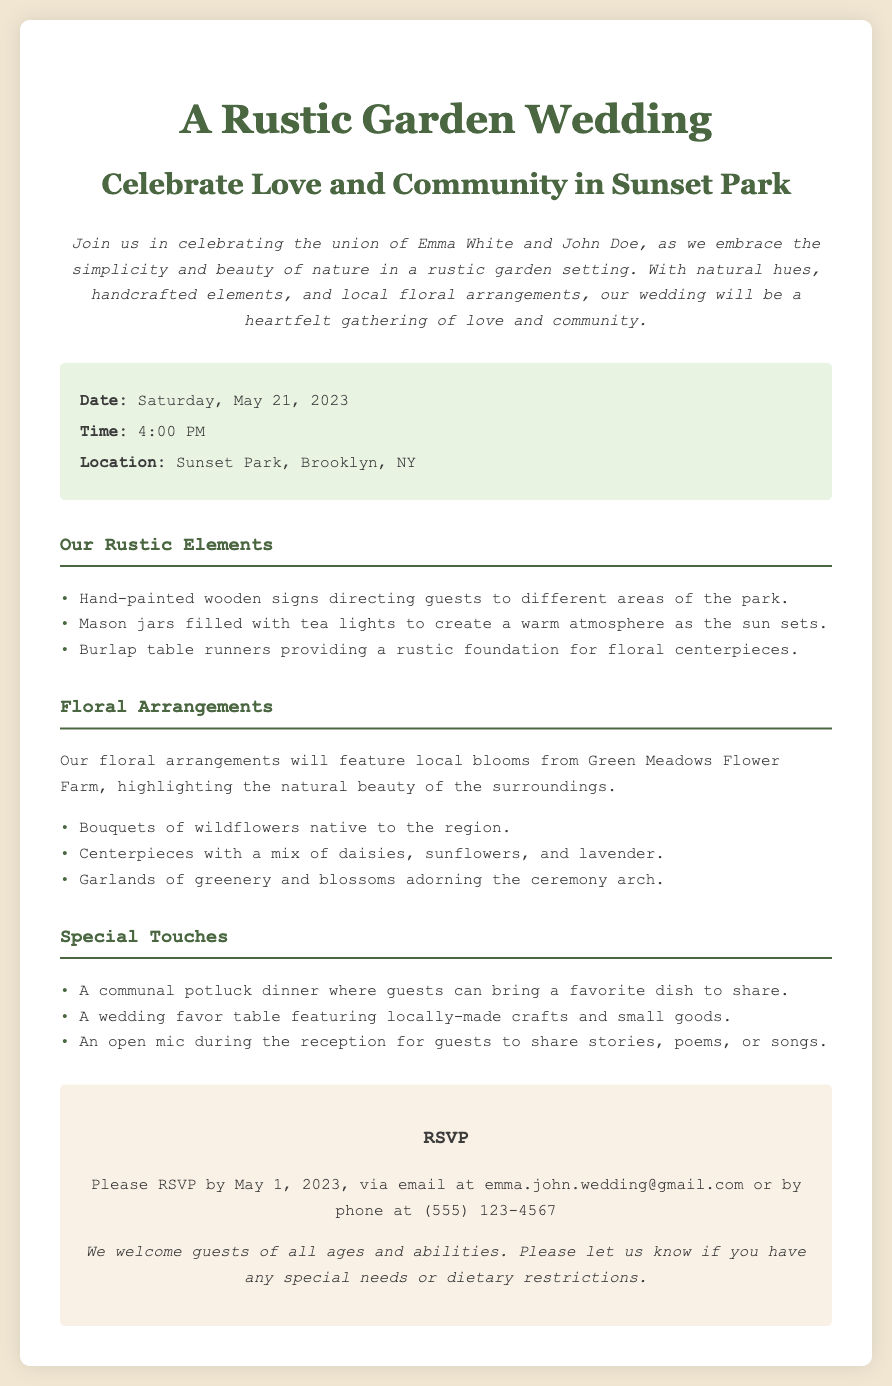What is the date of the wedding? The date of the wedding is stated in the details section of the document.
Answer: Saturday, May 21, 2023 What time does the wedding start? The time of the wedding is specifically mentioned in the details section.
Answer: 4:00 PM Where is the wedding location? The location is provided in the details section, specifying the venue for the wedding.
Answer: Sunset Park, Brooklyn, NY Who are the couple getting married? The couple's names are introduced in the introduction paragraph of the document.
Answer: Emma White and John Doe What is one type of floral arrangement mentioned? The document lists types of floral arrangements in the corresponding section.
Answer: Daisies What special activity involves guests sharing? The document describes a special touch in the reception section that allows guests to participate.
Answer: Open mic How should guests RSVP? The RSVP method is detailed in the RSVP section of the document.
Answer: Via email or phone What type of dinner is planned for the reception? The document includes information about the style of dinner being served to guests.
Answer: Communal potluck dinner What is emphasized in the wedding's theme? The overarching theme is mentioned at the beginning of the document, setting the tone for the event.
Answer: Simplicity and beauty of nature 